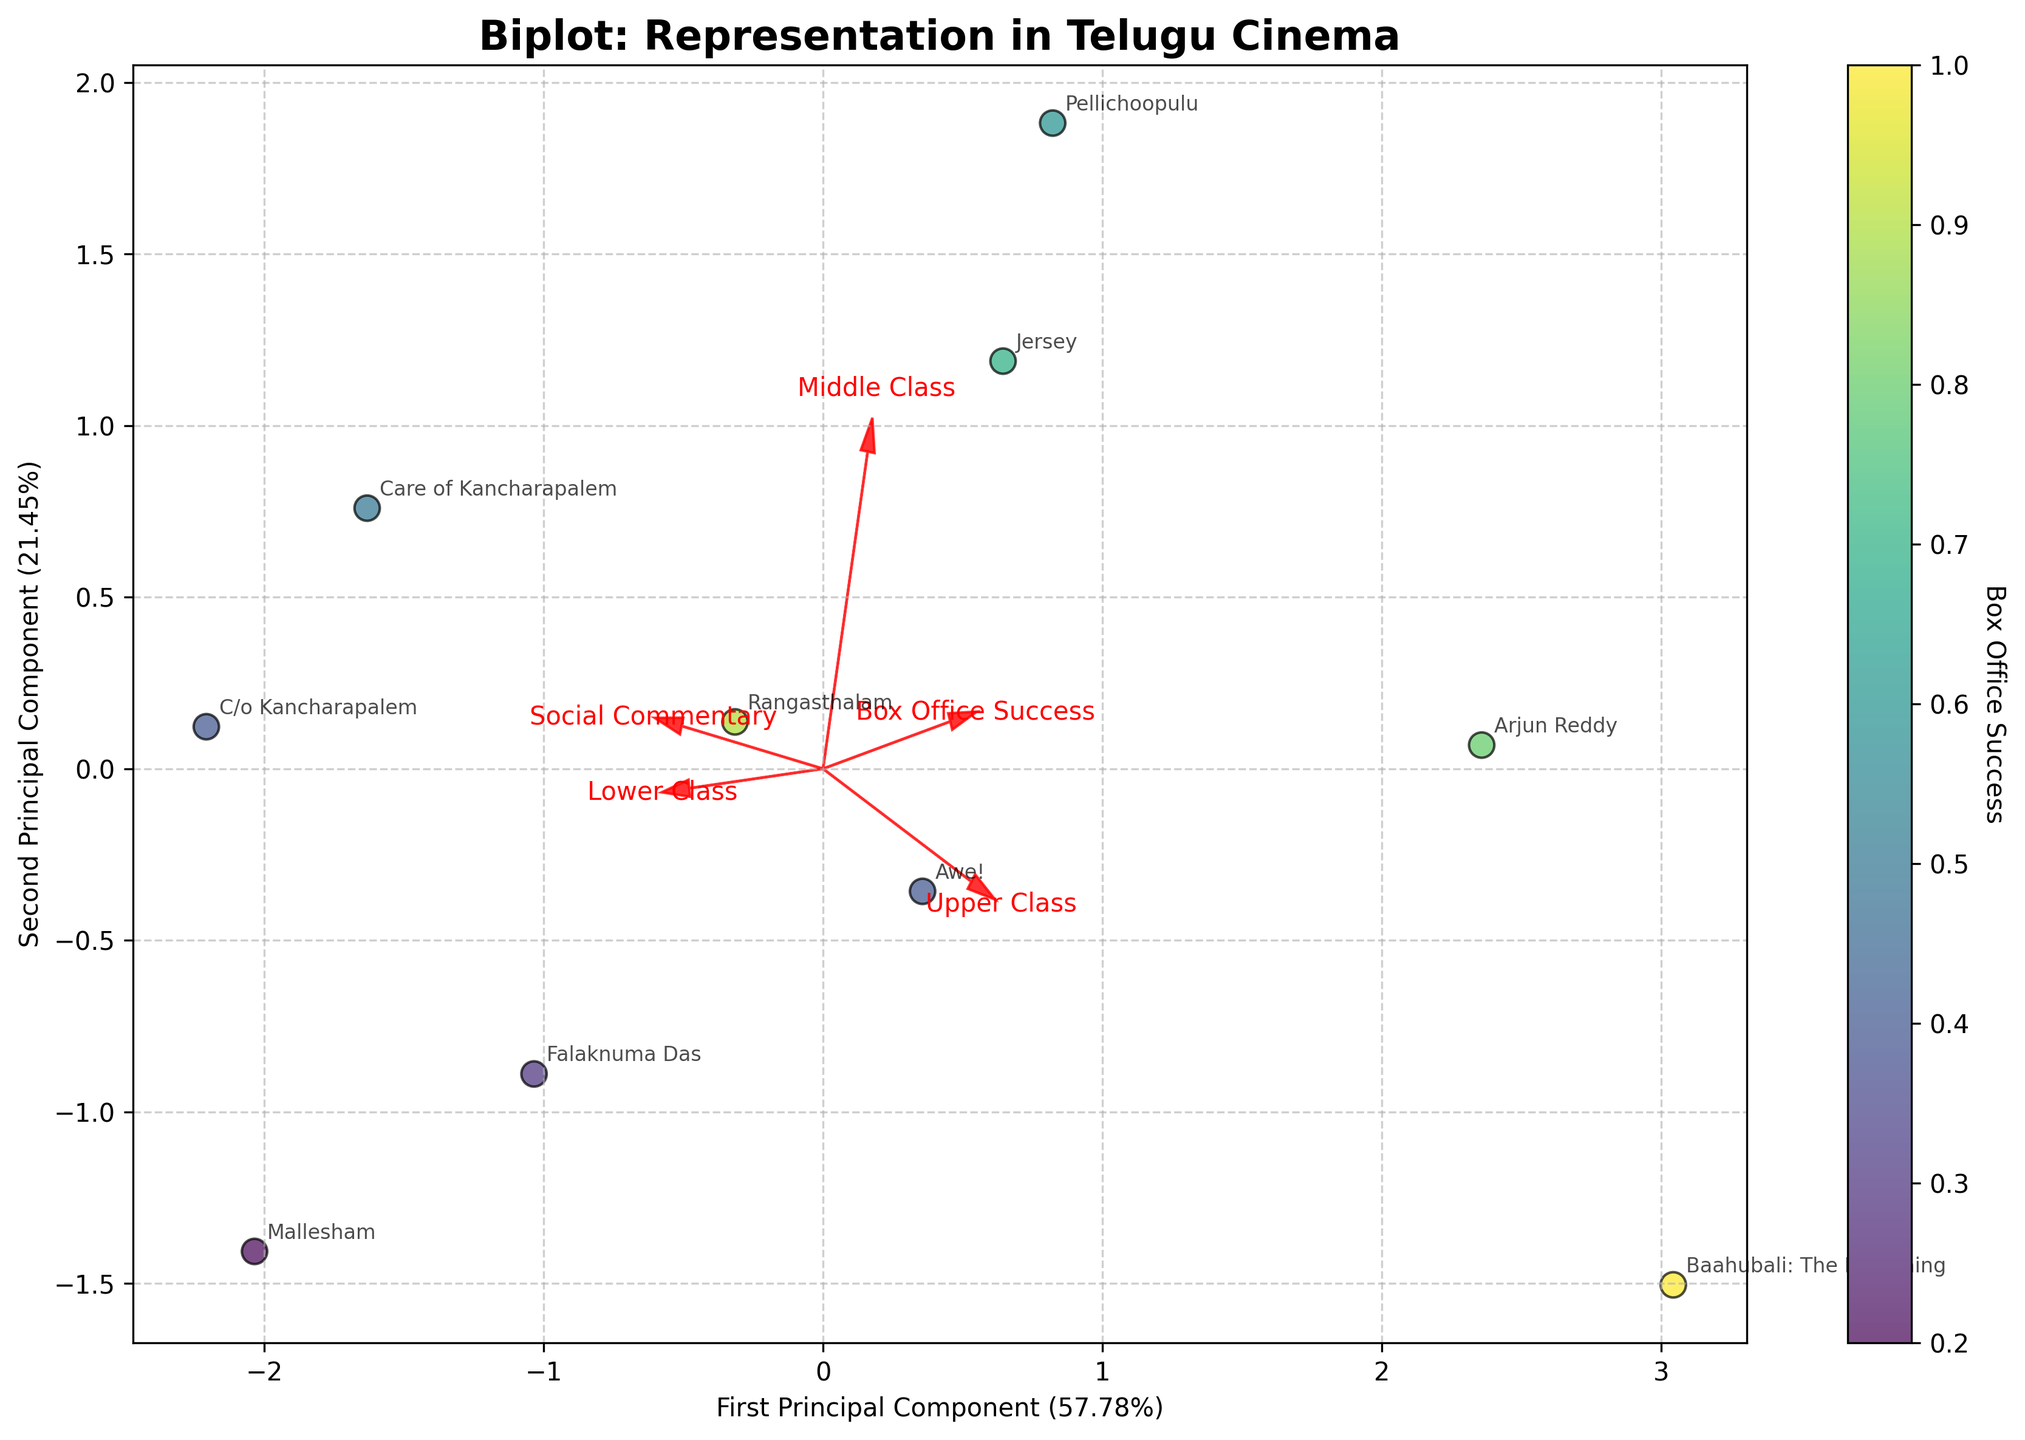What does the title of the plot indicate? The plot's title states 'Biplot: Representation in Telugu Cinema,' which indicates that the biplot visualizes the representation of different social classes and their relation to social commentary and box office success in Telugu cinema.
Answer: Biplot: Representation in Telugu Cinema How many principal components does the plot show? The plot shows two principal components, which are indicated by the axis labels 'First Principal Component' and 'Second Principal Component.'
Answer: Two Which film has the highest representation of the lower class? By tracing the data points and identifying the highest value on the feature vector corresponding to the lower class, we find 'Care of Kancharapalem' is the film with the highest representation of the lower class.
Answer: Care of Kancharapalem Which two films are closest in their principal component space? Observing the scatter plot, 'Care of Kancharapalem' and 'C/o Kancharapalem' are the closest data points in the principal component space, indicating their features are highly similar.
Answer: Care of Kancharapalem and C/o Kancharapalem What does the length and direction of the feature vectors represent? The length of the feature vectors represents the importance or weight of each feature in defining the principal components. The direction shows how each feature contributes to the principal components.
Answer: Importance and contribution direction What is the Box Office Success value range represented in the color scale? The color scale (viridis) provides a gradient where lighter colors represent higher box office success and darker colors represent lower success. Observing the scatter plot, the range goes from approximately 0.2 to 1.0.
Answer: 0.2 to 1.0 How is the representation of the upper class and middle class correlated on the plot? By following the direction of the feature vectors for the upper class and middle class, we see they point in opposite directions but are not exactly aligned, indicating a weak negative correlation.
Answer: Weak negative correlation Which movie has the highest social commentary score and low box office success? Identifying the data point with the highest value on the social commentary feature vector and a relatively darker color on the viridis scale, we find 'Mallesham' fits this criterion.
Answer: Mallesham Between 'Baahubali: The Beginning' and 'Jersey,' which film places more emphasis on upper class representation? By locating 'Baahubali: The Beginning' and 'Jersey' on the plot and comparing their positions relative to the upper class feature vector, 'Baahubali: The Beginning' is closer towards it, indicating more emphasis on upper class representation.
Answer: Baahubali: The Beginning 